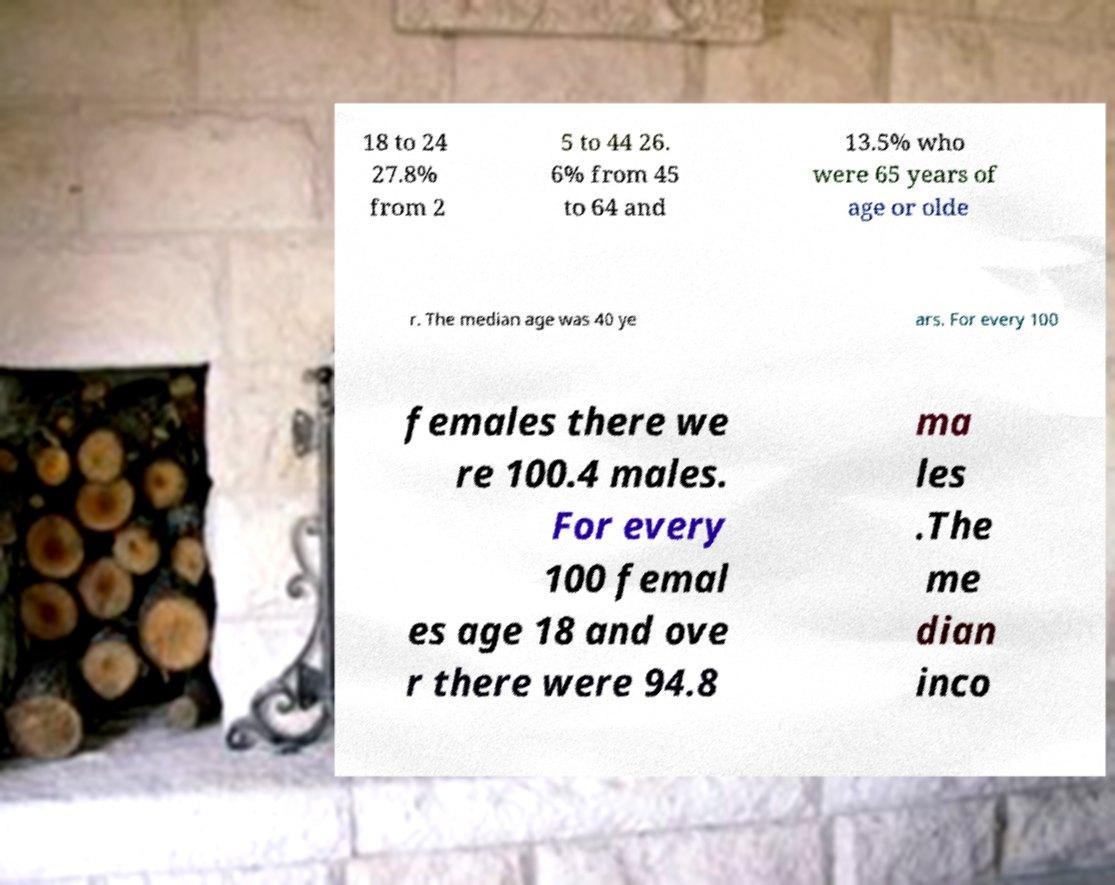Can you accurately transcribe the text from the provided image for me? 18 to 24 27.8% from 2 5 to 44 26. 6% from 45 to 64 and 13.5% who were 65 years of age or olde r. The median age was 40 ye ars. For every 100 females there we re 100.4 males. For every 100 femal es age 18 and ove r there were 94.8 ma les .The me dian inco 